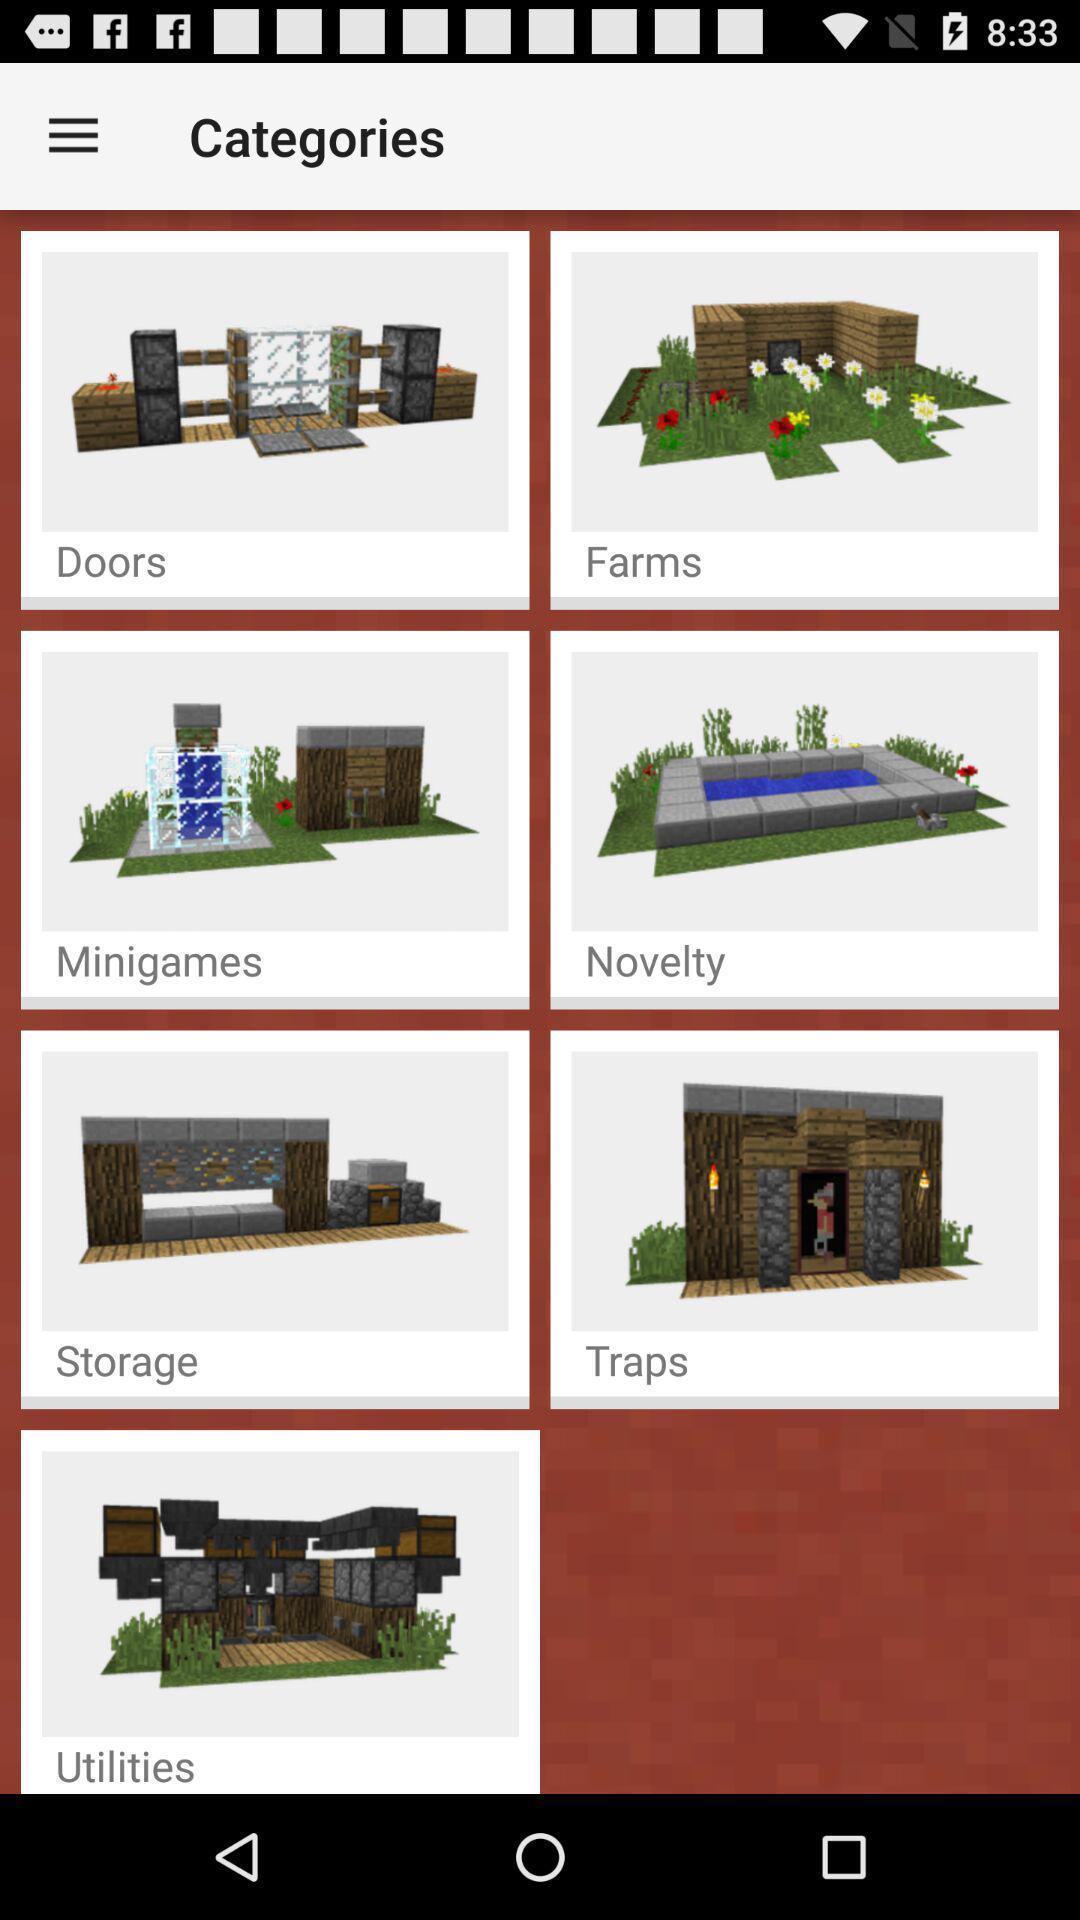Summarize the main components in this picture. Screen shows different icons of various categories. 